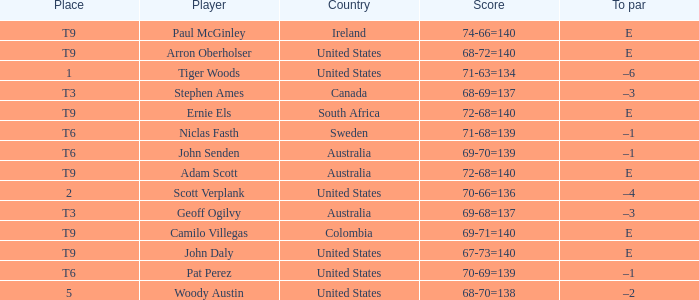Which player has a to par of e and a score of 67-73=140? John Daly. 